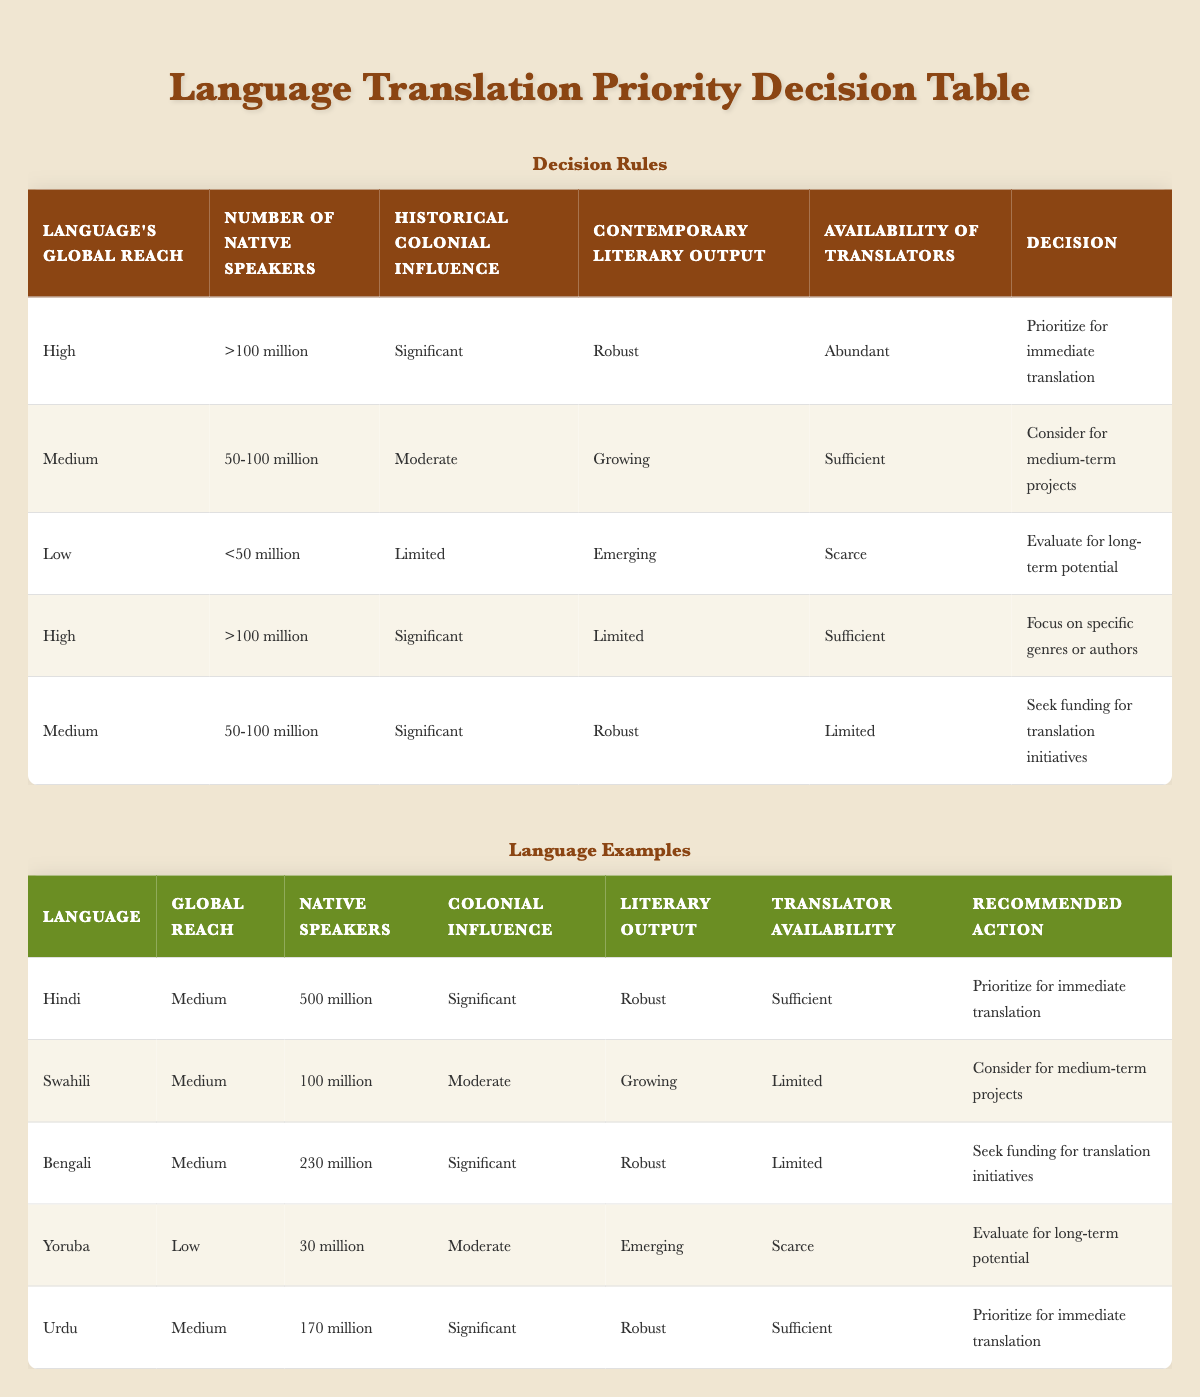What recommended action is suggested for Urdu? The table indicates that for Urdu, which has a medium global reach, 170 million native speakers, significant historical colonial influence, robust contemporary literary output, and sufficient availability of translators, the recommended action is to prioritize for immediate translation.
Answer: Prioritize for immediate translation How many native speakers does Swahili have? Referring to the table, Swahili has 100 million native speakers as indicated in the relevant row under the "Number of native speakers" column.
Answer: 100 million Is the historical colonial influence of Yoruba significant? The table shows that Yoruba has a moderate historical colonial influence, according to the details provided in the row corresponding to Yoruba.
Answer: No What is the average number of native speakers for the languages listed as "Medium" in global reach? The medium global reach languages are Hindi (500 million), Swahili (100 million), Bengali (230 million), and Urdu (170 million). To find the average, we sum these values: 500 + 100 + 230 + 170 = 1100 million. Then divide by the number of languages: 1100/4 = 275 million.
Answer: 275 million Which language has the highest global reach that is recommended to seek funding for translation initiatives? Analyzing the table, the only language under the recommendation to seek funding for translation initiatives is Bengali, which falls under medium global reach with significant historical colonial influence. This is the highest global reach for this recommendation.
Answer: Bengali What action is recommended for languages with limited contemporary literary output but significant colonial influence? The table specifies that for languages with high global reach, significant colonial influence, limited contemporary literary output, and sufficient availability of translators, the recommended action is to focus on specific genres or authors.
Answer: Focus on specific genres or authors Are there any languages listed with availability of translators classified as scarce? The table indicates that Yoruba has "scarce" availability of translators. Thus, there is indeed at least one language with this classification.
Answer: Yes Which language has the lowest number of native speakers and what is the recommended action for it? The table shows that Yoruba has the lowest number of native speakers with 30 million, and the recommended action for Yoruba is to evaluate for long-term potential.
Answer: Evaluate for long-term potential 